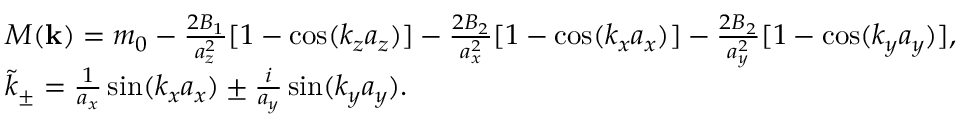<formula> <loc_0><loc_0><loc_500><loc_500>\begin{array} { r l } & { M ( { k } ) = m _ { 0 } - \frac { 2 B _ { 1 } } { a _ { z } ^ { 2 } } [ 1 - \cos ( k _ { z } a _ { z } ) ] - \frac { 2 B _ { 2 } } { a _ { x } ^ { 2 } } [ 1 - \cos ( k _ { x } a _ { x } ) ] - \frac { 2 B _ { 2 } } { a _ { y } ^ { 2 } } [ 1 - \cos ( k _ { y } a _ { y } ) ] , } \\ & { \tilde { k } _ { \pm } = \frac { 1 } { a _ { x } } \sin ( k _ { x } a _ { x } ) \pm \frac { i } { a _ { y } } \sin ( k _ { y } a _ { y } ) . } \end{array}</formula> 